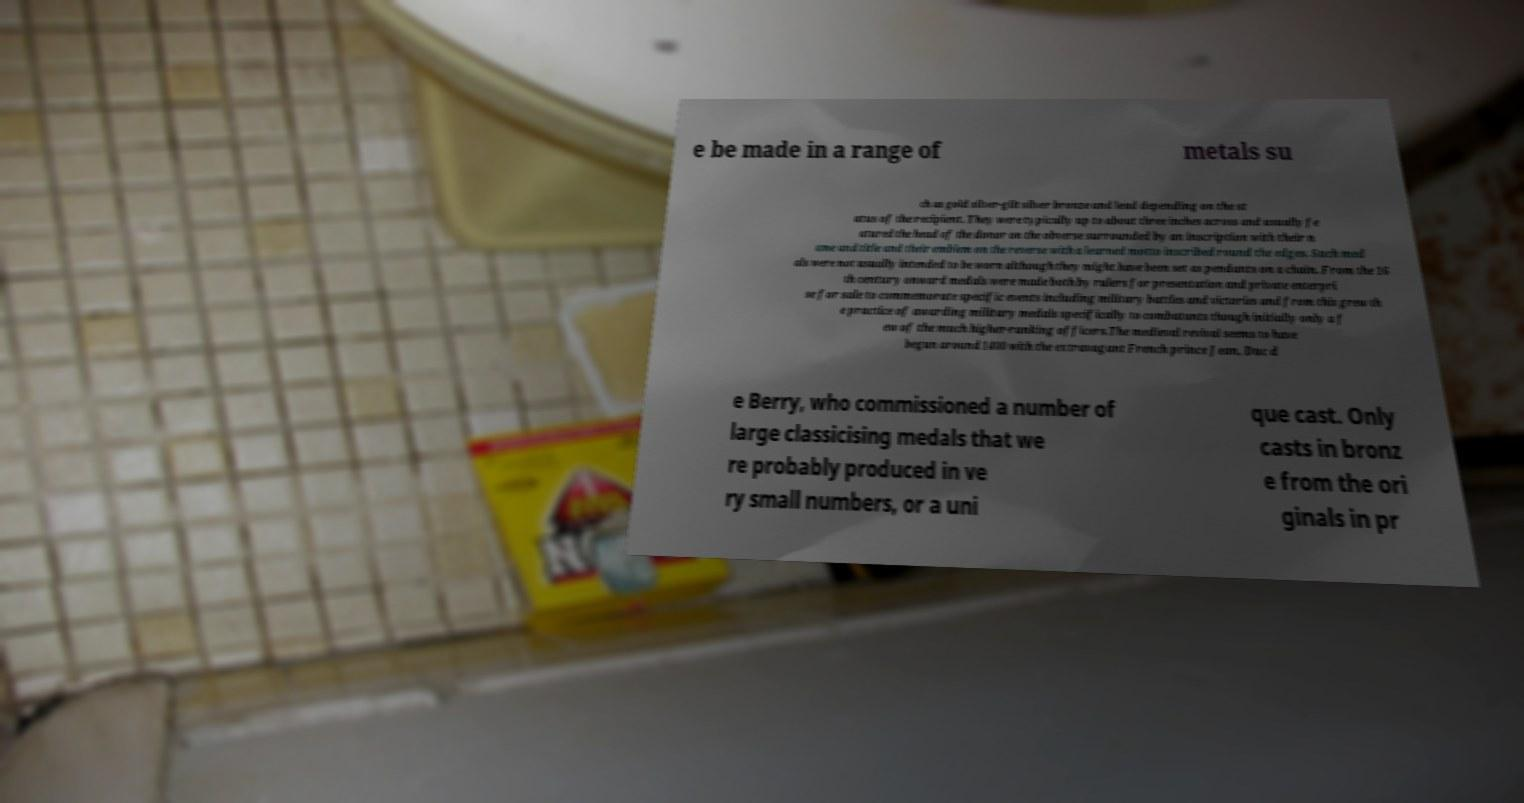For documentation purposes, I need the text within this image transcribed. Could you provide that? e be made in a range of metals su ch as gold silver-gilt silver bronze and lead depending on the st atus of the recipient. They were typically up to about three inches across and usually fe atured the head of the donor on the obverse surrounded by an inscription with their n ame and title and their emblem on the reverse with a learned motto inscribed round the edges. Such med als were not usually intended to be worn although they might have been set as pendants on a chain. From the 16 th century onward medals were made both by rulers for presentation and private enterpri se for sale to commemorate specific events including military battles and victories and from this grew th e practice of awarding military medals specifically to combatants though initially only a f ew of the much higher-ranking officers.The medieval revival seems to have begun around 1400 with the extravagant French prince Jean, Duc d e Berry, who commissioned a number of large classicising medals that we re probably produced in ve ry small numbers, or a uni que cast. Only casts in bronz e from the ori ginals in pr 